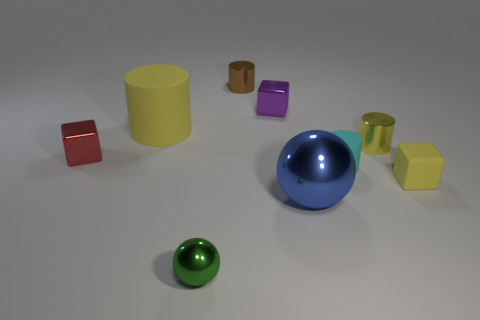Add 1 big green rubber cubes. How many objects exist? 10 Subtract all spheres. How many objects are left? 7 Subtract 1 brown cylinders. How many objects are left? 8 Subtract all rubber blocks. Subtract all green spheres. How many objects are left? 7 Add 4 big yellow cylinders. How many big yellow cylinders are left? 5 Add 3 tiny yellow things. How many tiny yellow things exist? 5 